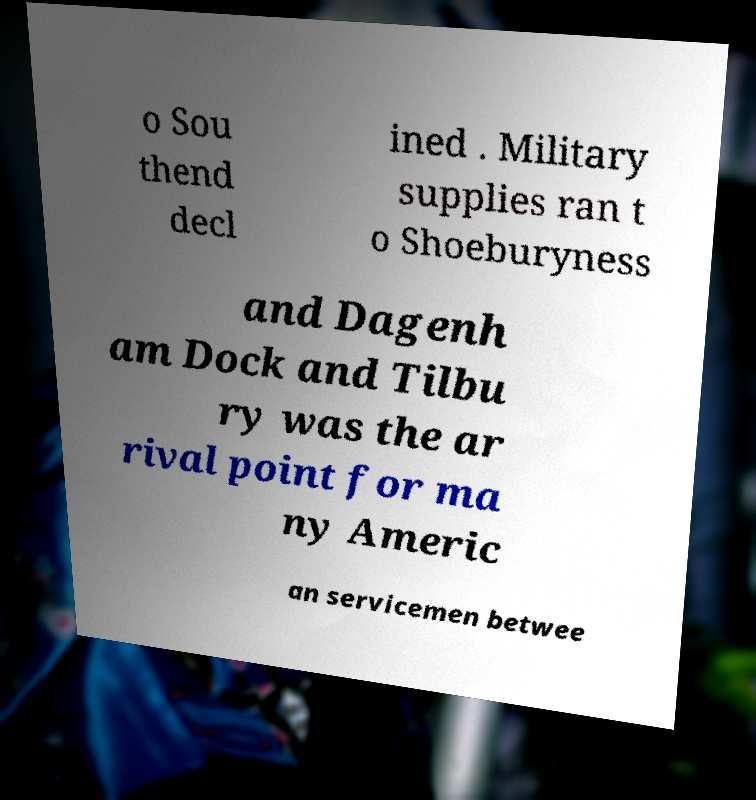There's text embedded in this image that I need extracted. Can you transcribe it verbatim? o Sou thend decl ined . Military supplies ran t o Shoeburyness and Dagenh am Dock and Tilbu ry was the ar rival point for ma ny Americ an servicemen betwee 